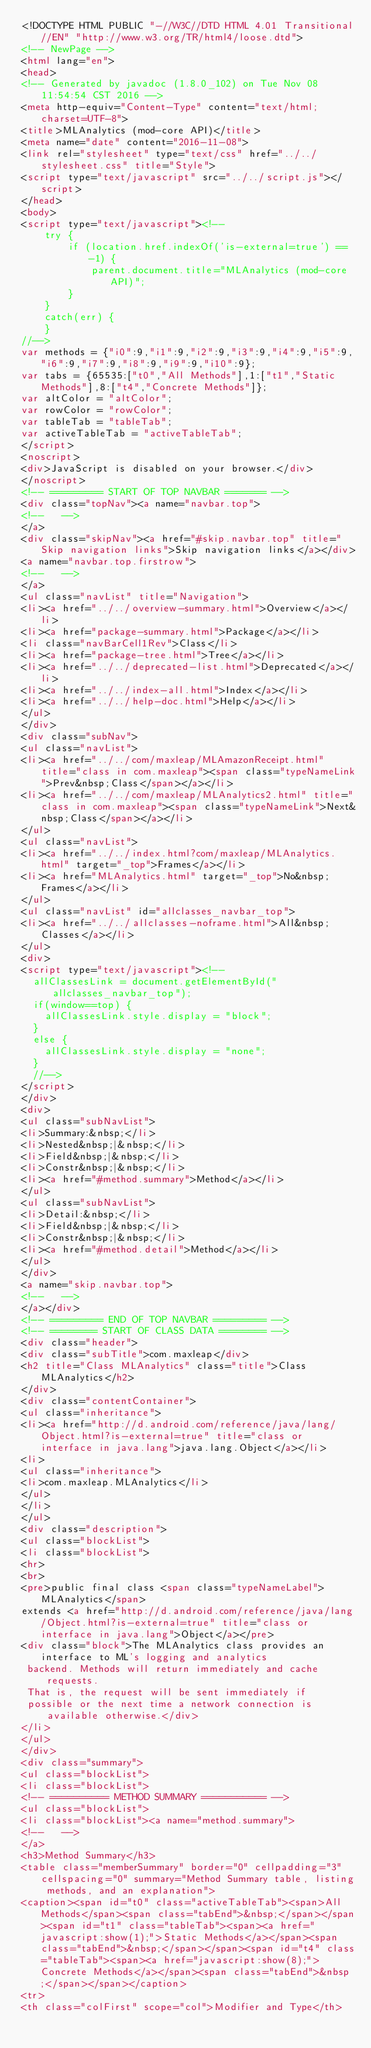Convert code to text. <code><loc_0><loc_0><loc_500><loc_500><_HTML_><!DOCTYPE HTML PUBLIC "-//W3C//DTD HTML 4.01 Transitional//EN" "http://www.w3.org/TR/html4/loose.dtd">
<!-- NewPage -->
<html lang="en">
<head>
<!-- Generated by javadoc (1.8.0_102) on Tue Nov 08 11:54:54 CST 2016 -->
<meta http-equiv="Content-Type" content="text/html; charset=UTF-8">
<title>MLAnalytics (mod-core API)</title>
<meta name="date" content="2016-11-08">
<link rel="stylesheet" type="text/css" href="../../stylesheet.css" title="Style">
<script type="text/javascript" src="../../script.js"></script>
</head>
<body>
<script type="text/javascript"><!--
    try {
        if (location.href.indexOf('is-external=true') == -1) {
            parent.document.title="MLAnalytics (mod-core API)";
        }
    }
    catch(err) {
    }
//-->
var methods = {"i0":9,"i1":9,"i2":9,"i3":9,"i4":9,"i5":9,"i6":9,"i7":9,"i8":9,"i9":9,"i10":9};
var tabs = {65535:["t0","All Methods"],1:["t1","Static Methods"],8:["t4","Concrete Methods"]};
var altColor = "altColor";
var rowColor = "rowColor";
var tableTab = "tableTab";
var activeTableTab = "activeTableTab";
</script>
<noscript>
<div>JavaScript is disabled on your browser.</div>
</noscript>
<!-- ========= START OF TOP NAVBAR ======= -->
<div class="topNav"><a name="navbar.top">
<!--   -->
</a>
<div class="skipNav"><a href="#skip.navbar.top" title="Skip navigation links">Skip navigation links</a></div>
<a name="navbar.top.firstrow">
<!--   -->
</a>
<ul class="navList" title="Navigation">
<li><a href="../../overview-summary.html">Overview</a></li>
<li><a href="package-summary.html">Package</a></li>
<li class="navBarCell1Rev">Class</li>
<li><a href="package-tree.html">Tree</a></li>
<li><a href="../../deprecated-list.html">Deprecated</a></li>
<li><a href="../../index-all.html">Index</a></li>
<li><a href="../../help-doc.html">Help</a></li>
</ul>
</div>
<div class="subNav">
<ul class="navList">
<li><a href="../../com/maxleap/MLAmazonReceipt.html" title="class in com.maxleap"><span class="typeNameLink">Prev&nbsp;Class</span></a></li>
<li><a href="../../com/maxleap/MLAnalytics2.html" title="class in com.maxleap"><span class="typeNameLink">Next&nbsp;Class</span></a></li>
</ul>
<ul class="navList">
<li><a href="../../index.html?com/maxleap/MLAnalytics.html" target="_top">Frames</a></li>
<li><a href="MLAnalytics.html" target="_top">No&nbsp;Frames</a></li>
</ul>
<ul class="navList" id="allclasses_navbar_top">
<li><a href="../../allclasses-noframe.html">All&nbsp;Classes</a></li>
</ul>
<div>
<script type="text/javascript"><!--
  allClassesLink = document.getElementById("allclasses_navbar_top");
  if(window==top) {
    allClassesLink.style.display = "block";
  }
  else {
    allClassesLink.style.display = "none";
  }
  //-->
</script>
</div>
<div>
<ul class="subNavList">
<li>Summary:&nbsp;</li>
<li>Nested&nbsp;|&nbsp;</li>
<li>Field&nbsp;|&nbsp;</li>
<li>Constr&nbsp;|&nbsp;</li>
<li><a href="#method.summary">Method</a></li>
</ul>
<ul class="subNavList">
<li>Detail:&nbsp;</li>
<li>Field&nbsp;|&nbsp;</li>
<li>Constr&nbsp;|&nbsp;</li>
<li><a href="#method.detail">Method</a></li>
</ul>
</div>
<a name="skip.navbar.top">
<!--   -->
</a></div>
<!-- ========= END OF TOP NAVBAR ========= -->
<!-- ======== START OF CLASS DATA ======== -->
<div class="header">
<div class="subTitle">com.maxleap</div>
<h2 title="Class MLAnalytics" class="title">Class MLAnalytics</h2>
</div>
<div class="contentContainer">
<ul class="inheritance">
<li><a href="http://d.android.com/reference/java/lang/Object.html?is-external=true" title="class or interface in java.lang">java.lang.Object</a></li>
<li>
<ul class="inheritance">
<li>com.maxleap.MLAnalytics</li>
</ul>
</li>
</ul>
<div class="description">
<ul class="blockList">
<li class="blockList">
<hr>
<br>
<pre>public final class <span class="typeNameLabel">MLAnalytics</span>
extends <a href="http://d.android.com/reference/java/lang/Object.html?is-external=true" title="class or interface in java.lang">Object</a></pre>
<div class="block">The MLAnalytics class provides an interface to ML's logging and analytics
 backend. Methods will return immediately and cache requests.
 That is, the request will be sent immediately if
 possible or the next time a network connection is available otherwise.</div>
</li>
</ul>
</div>
<div class="summary">
<ul class="blockList">
<li class="blockList">
<!-- ========== METHOD SUMMARY =========== -->
<ul class="blockList">
<li class="blockList"><a name="method.summary">
<!--   -->
</a>
<h3>Method Summary</h3>
<table class="memberSummary" border="0" cellpadding="3" cellspacing="0" summary="Method Summary table, listing methods, and an explanation">
<caption><span id="t0" class="activeTableTab"><span>All Methods</span><span class="tabEnd">&nbsp;</span></span><span id="t1" class="tableTab"><span><a href="javascript:show(1);">Static Methods</a></span><span class="tabEnd">&nbsp;</span></span><span id="t4" class="tableTab"><span><a href="javascript:show(8);">Concrete Methods</a></span><span class="tabEnd">&nbsp;</span></span></caption>
<tr>
<th class="colFirst" scope="col">Modifier and Type</th></code> 